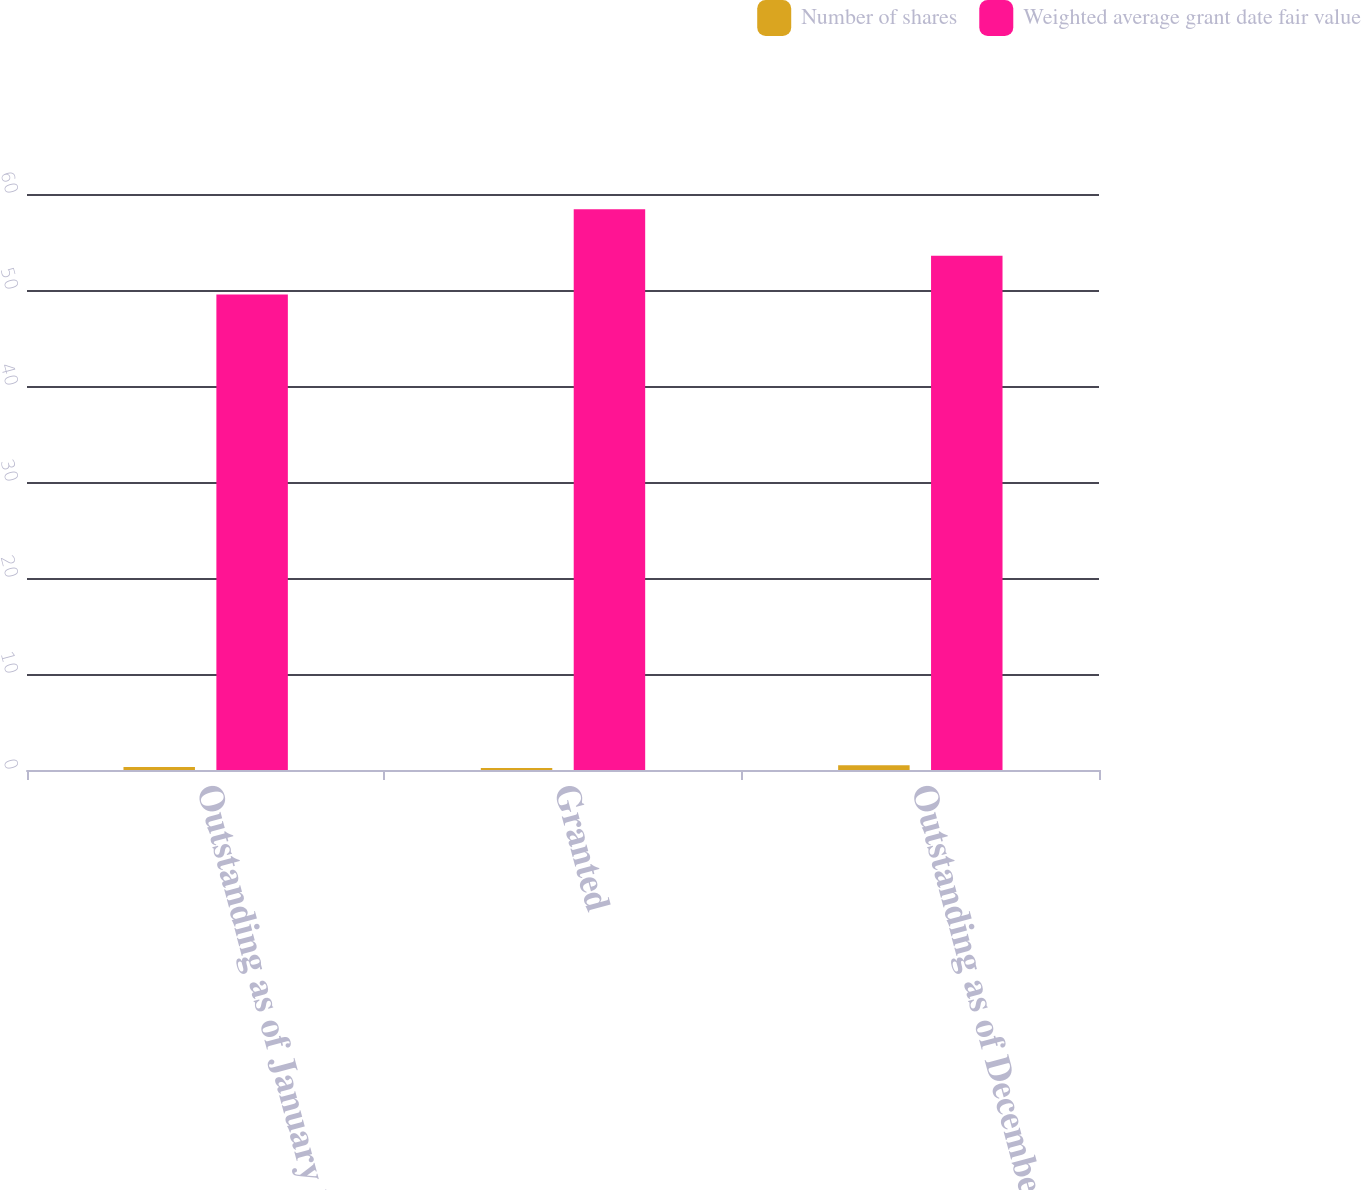Convert chart. <chart><loc_0><loc_0><loc_500><loc_500><stacked_bar_chart><ecel><fcel>Outstanding as of January 1<fcel>Granted<fcel>Outstanding as of December 31<nl><fcel>Number of shares<fcel>0.3<fcel>0.2<fcel>0.5<nl><fcel>Weighted average grant date fair value<fcel>49.54<fcel>58.4<fcel>53.56<nl></chart> 